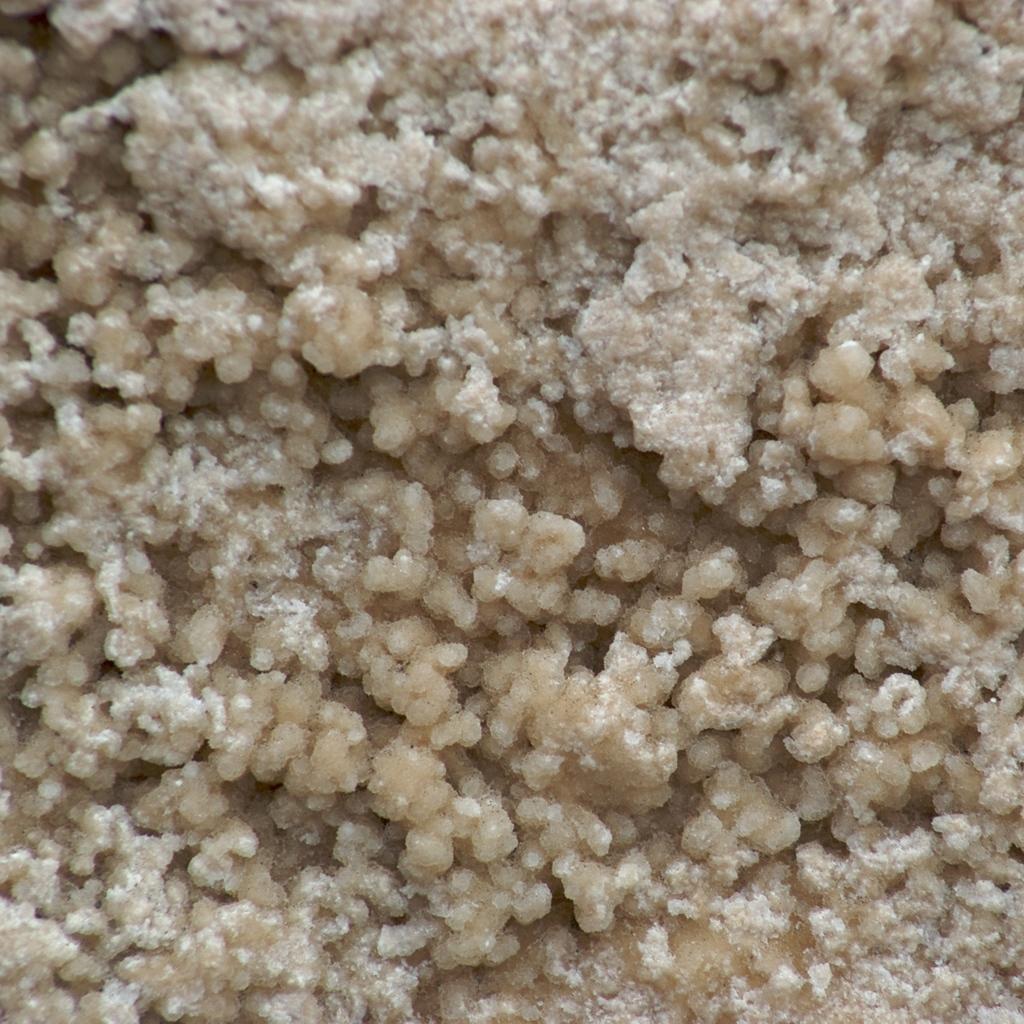In one or two sentences, can you explain what this image depicts? In this image we can see some food item. 